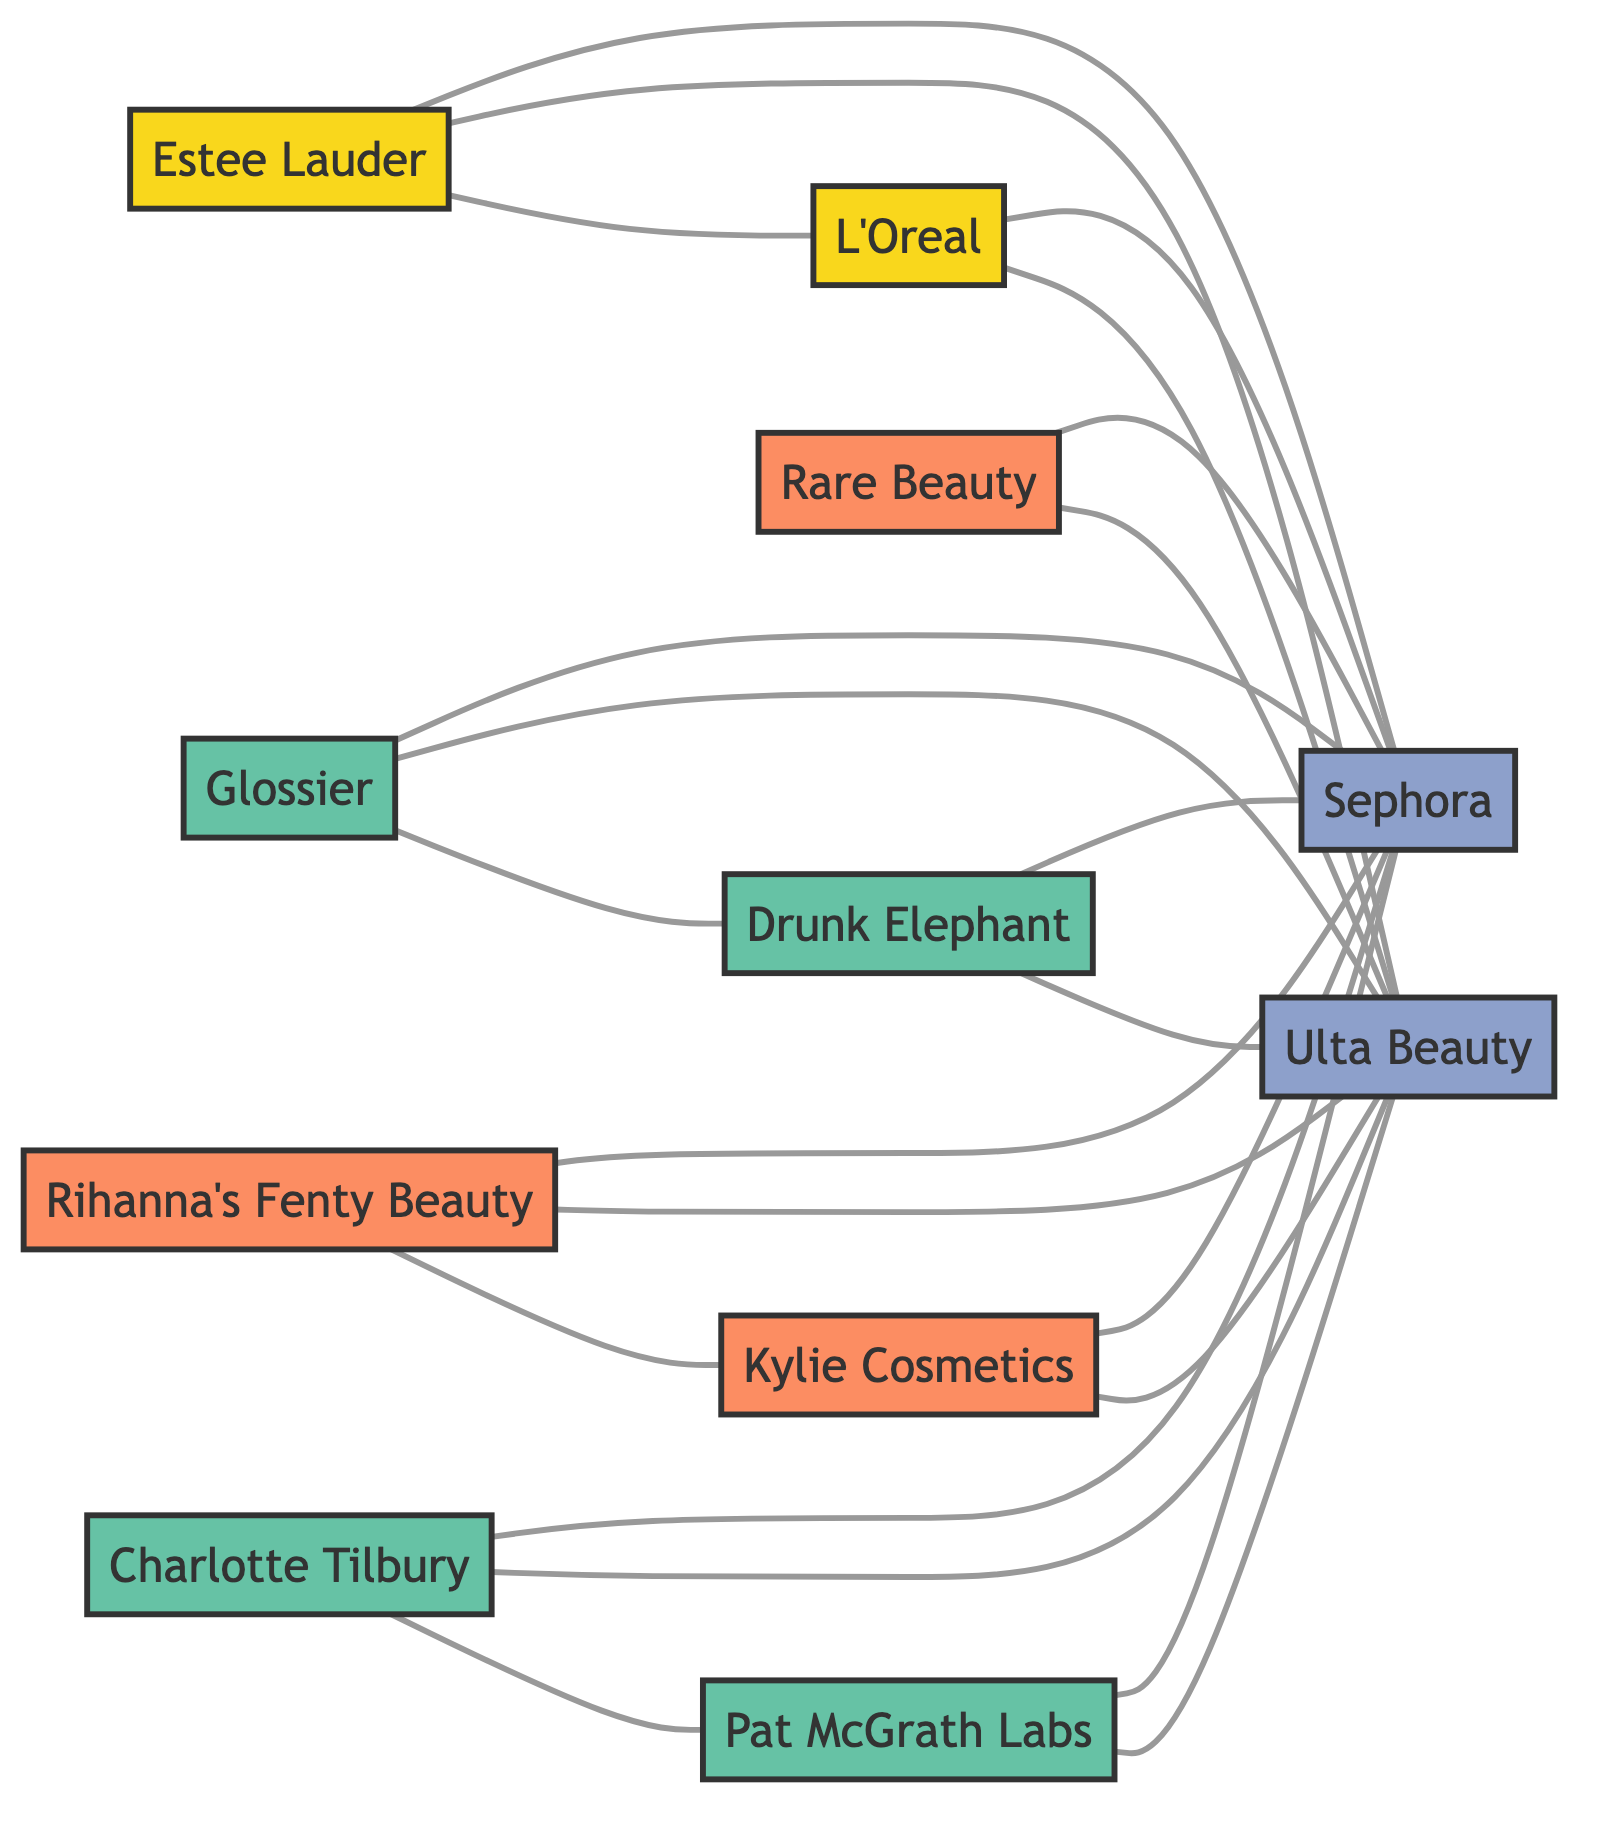What's the total number of nodes in the diagram? To determine the total number of nodes, we count each unique entity represented in the diagram: Estee Lauder, L'Oreal, Sephora, Glossier, Rihanna's Fenty Beauty, Ulta Beauty, Drunk Elephant, Kylie Cosmetics, Rare Beauty by Selena Gomez, Charlotte Tilbury, and Pat McGrath Labs. There are 11 nodes in total.
Answer: 11 Which retailer is connected to the most brands? By analyzing the connections shown in the diagram, we find that both Sephora and Ulta Beauty are connected to all startups and established brands listed. Since they both have identical edges, they each connect to 10 brands.
Answer: Sephora and Ulta Beauty How many edges connect to the startup Glossier? We examine the edges connected to Glossier: it connects to Sephora, Ulta Beauty, and Drunk Elephant, making a total of 3 edges.
Answer: 3 Which established brand is linked to L'Oreal? Looking at the connections, L'Oreal is connected to Estee Lauder, as seen directly in the edge between these two nodes.
Answer: Estee Lauder Is there a connection between the startup Charlotte Tilbury and any celebrity brand? We check all edges for connections with Charlotte Tilbury. It is connected to Pat McGrath Labs but not directly to any celebrity brands such as Rihanna's Fenty Beauty, Kylie Cosmetics, or Rare Beauty. Hence, there is no direct connection to any celebrity brand.
Answer: No Which startup has a direct competition with Drunk Elephant? Upon reviewing the edges, the only startup directly connected to Drunk Elephant is Glossier. Thus, Glossier represents direct competition.
Answer: Glossier What type of brand is Rihanna's Fenty Beauty? The diagram categorizes Rihanna's Fenty Beauty as a Celebrity Brand according to its node classification.
Answer: Celebrity Brand How many edges are there in total? To find the total edges, we count each connection listed in the data. There are 20 edges displayed in the diagram, indicating the relationships between the nodes.
Answer: 20 Which two brands are connected by a competition link? By analyzing the edges, we find that Rihanna's Fenty Beauty and Kylie Cosmetics are directly connected, indicating a competitive relationship between these two celebrity brands.
Answer: Rihanna's Fenty Beauty and Kylie Cosmetics 